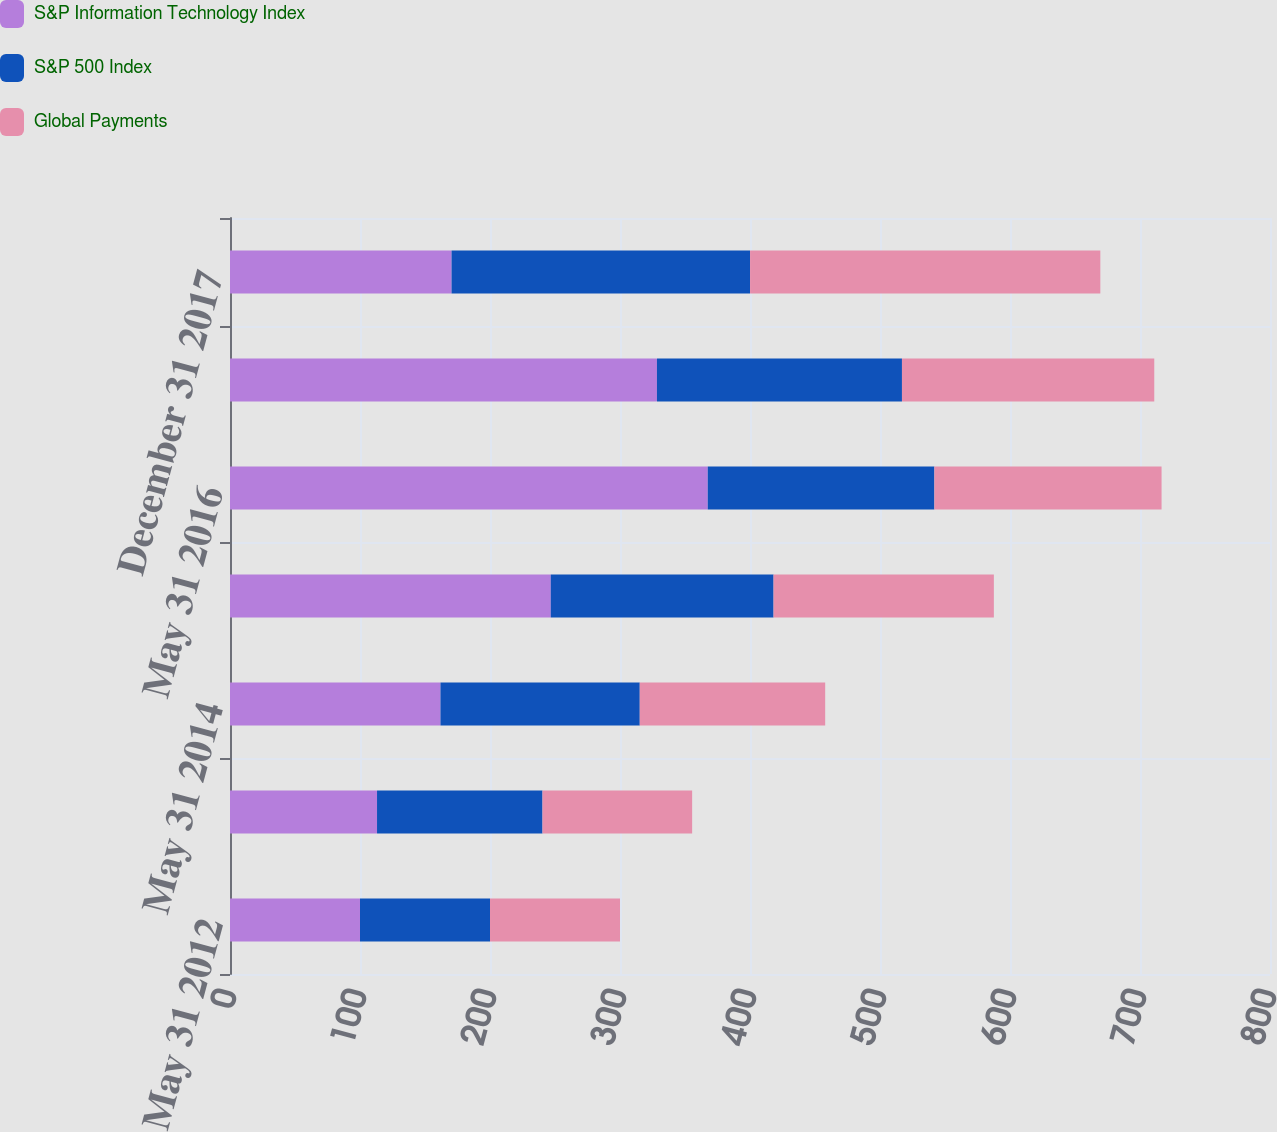<chart> <loc_0><loc_0><loc_500><loc_500><stacked_bar_chart><ecel><fcel>May 31 2012<fcel>May 31 2013<fcel>May 31 2014<fcel>May 31 2015<fcel>May 31 2016<fcel>December 31 2016<fcel>December 31 2017<nl><fcel>S&P Information Technology Index<fcel>100<fcel>113.1<fcel>161.9<fcel>246.72<fcel>367.5<fcel>328.42<fcel>170.43<nl><fcel>S&P 500 Index<fcel>100<fcel>127.28<fcel>153.3<fcel>171.4<fcel>174.34<fcel>188.47<fcel>229.61<nl><fcel>Global Payments<fcel>100<fcel>115.12<fcel>142.63<fcel>169.46<fcel>174.75<fcel>194.08<fcel>269.45<nl></chart> 